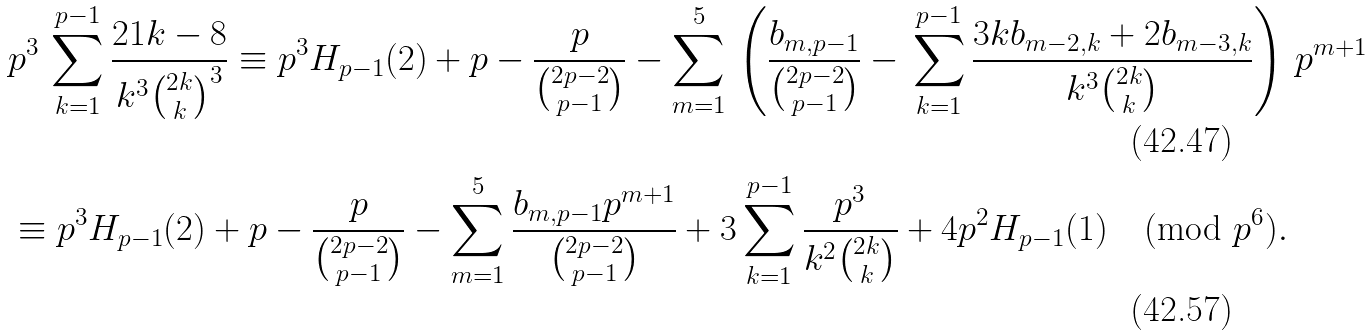Convert formula to latex. <formula><loc_0><loc_0><loc_500><loc_500>& p ^ { 3 } \, \sum _ { k = 1 } ^ { p - 1 } \frac { 2 1 k - 8 } { k ^ { 3 } \binom { 2 k } { k } ^ { 3 } } \equiv p ^ { 3 } H _ { p - 1 } ( 2 ) + p - \frac { p } { \binom { 2 p - 2 } { p - 1 } } - \sum _ { m = 1 } ^ { 5 } \, \left ( \frac { b _ { m , p - 1 } } { \binom { 2 p - 2 } { p - 1 } } - \, \sum _ { k = 1 } ^ { p - 1 } \frac { 3 k b _ { m - 2 , k } + 2 b _ { m - 3 , k } } { k ^ { 3 } \binom { 2 k } { k } } \right ) \, p ^ { m + 1 } \\ & \equiv p ^ { 3 } H _ { p - 1 } ( 2 ) + p - \frac { p } { \binom { 2 p - 2 } { p - 1 } } - \sum _ { m = 1 } ^ { 5 } \frac { b _ { m , p - 1 } p ^ { m + 1 } } { \binom { 2 p - 2 } { p - 1 } } + 3 \sum _ { k = 1 } ^ { p - 1 } \frac { p ^ { 3 } } { k ^ { 2 } \binom { 2 k } { k } } + 4 p ^ { 2 } H _ { p - 1 } ( 1 ) \pmod { p ^ { 6 } } .</formula> 